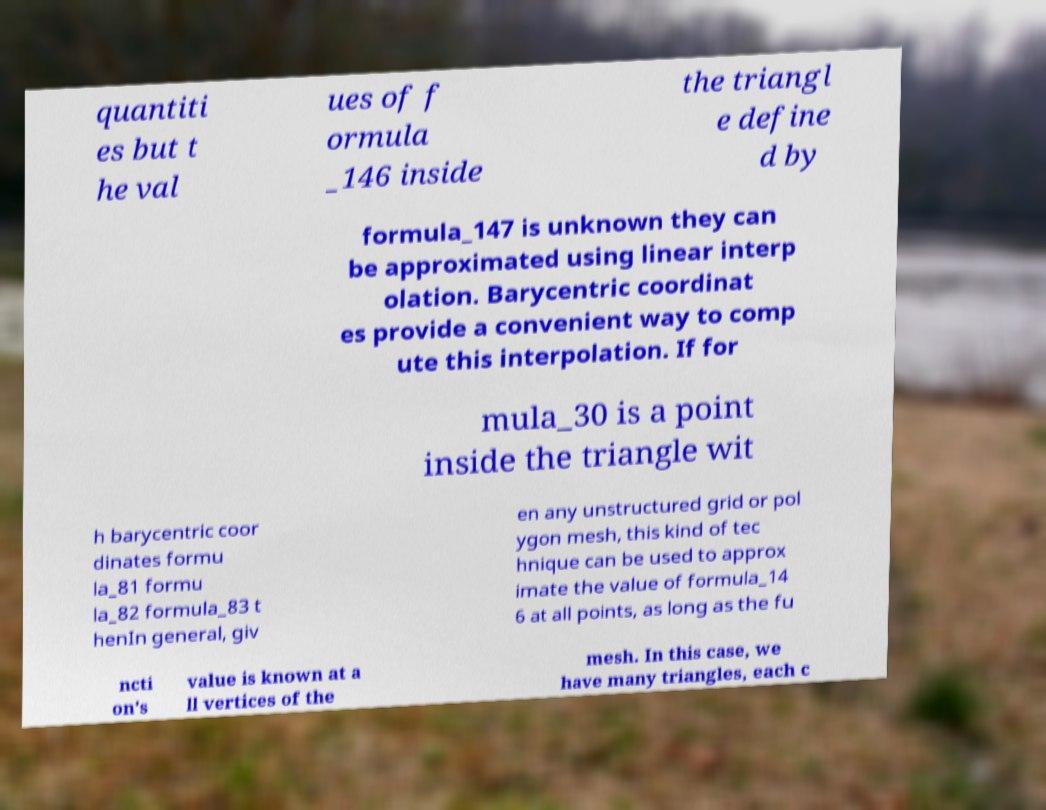Could you extract and type out the text from this image? quantiti es but t he val ues of f ormula _146 inside the triangl e define d by formula_147 is unknown they can be approximated using linear interp olation. Barycentric coordinat es provide a convenient way to comp ute this interpolation. If for mula_30 is a point inside the triangle wit h barycentric coor dinates formu la_81 formu la_82 formula_83 t henIn general, giv en any unstructured grid or pol ygon mesh, this kind of tec hnique can be used to approx imate the value of formula_14 6 at all points, as long as the fu ncti on's value is known at a ll vertices of the mesh. In this case, we have many triangles, each c 